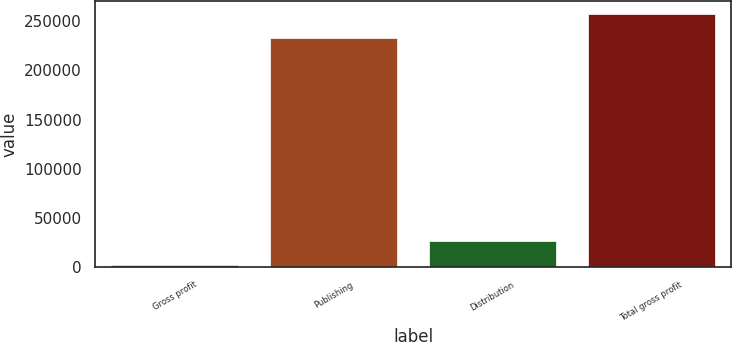Convert chart. <chart><loc_0><loc_0><loc_500><loc_500><bar_chart><fcel>Gross profit<fcel>Publishing<fcel>Distribution<fcel>Total gross profit<nl><fcel>2009<fcel>232990<fcel>26874.3<fcel>257855<nl></chart> 